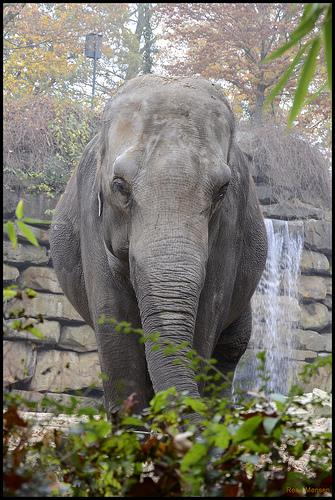Question: where was this photo taken?
Choices:
A. At the zoo.
B. The Lake.
C. A party.
D. The woods.
Answer with the letter. Answer: A Question: when was this photo taken?
Choices:
A. During the day.
B. Early morning.
C. Midnight.
D. Late night.
Answer with the letter. Answer: A Question: why is this photo illuminated?
Choices:
A. Candle light.
B. Light bulb light.
C. Fire light.
D. Sunlight.
Answer with the letter. Answer: D Question: what color is the elephant?
Choices:
A. Gray.
B. Brown.
C. Gray and brown.
D. White.
Answer with the letter. Answer: A Question: what color are the leaves?
Choices:
A. Brown.
B. Green.
C. Orange.
D. Yellow.
Answer with the letter. Answer: B Question: how many elephants are there?
Choices:
A. One.
B. Two.
C. Three.
D. None.
Answer with the letter. Answer: A 